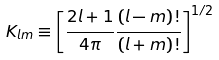Convert formula to latex. <formula><loc_0><loc_0><loc_500><loc_500>K _ { l m } \equiv \left [ \frac { 2 l + 1 } { 4 \pi } \frac { ( l - m ) ! } { ( l + m ) ! } \right ] ^ { 1 / 2 }</formula> 